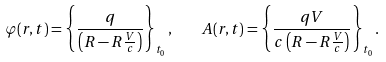<formula> <loc_0><loc_0><loc_500><loc_500>\varphi ( { r } , t ) = \left \{ \frac { q } { \left ( R - { R } \frac { V } { c } \right ) } \right \} _ { t _ { 0 } } , \quad { A } ( { r } , t ) = \left \{ \frac { q { V } } { c \left ( R - { R } \frac { V } { c } \right ) } \right \} _ { t _ { 0 } } .</formula> 